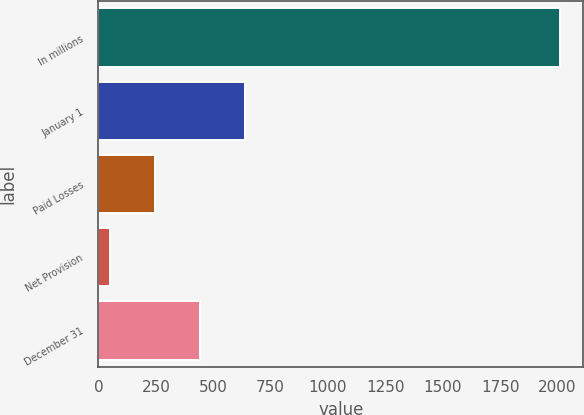Convert chart. <chart><loc_0><loc_0><loc_500><loc_500><bar_chart><fcel>In millions<fcel>January 1<fcel>Paid Losses<fcel>Net Provision<fcel>December 31<nl><fcel>2010<fcel>638.7<fcel>246.9<fcel>51<fcel>442.8<nl></chart> 